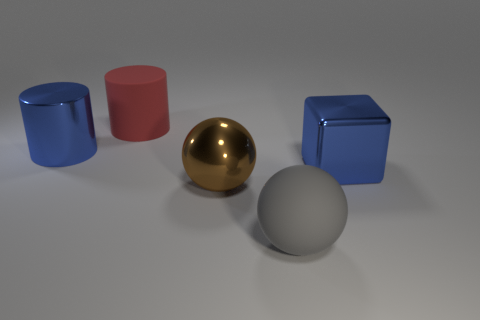Subtract all purple cubes. Subtract all red cylinders. How many cubes are left? 1 Subtract all brown cylinders. How many purple spheres are left? 0 Subtract all metal things. Subtract all red balls. How many objects are left? 2 Add 2 large blue metallic cylinders. How many large blue metallic cylinders are left? 3 Add 5 gray things. How many gray things exist? 6 Add 2 blue blocks. How many objects exist? 7 Subtract all blue cylinders. How many cylinders are left? 1 Subtract 0 yellow balls. How many objects are left? 5 Subtract all cubes. How many objects are left? 4 Subtract 1 spheres. How many spheres are left? 1 